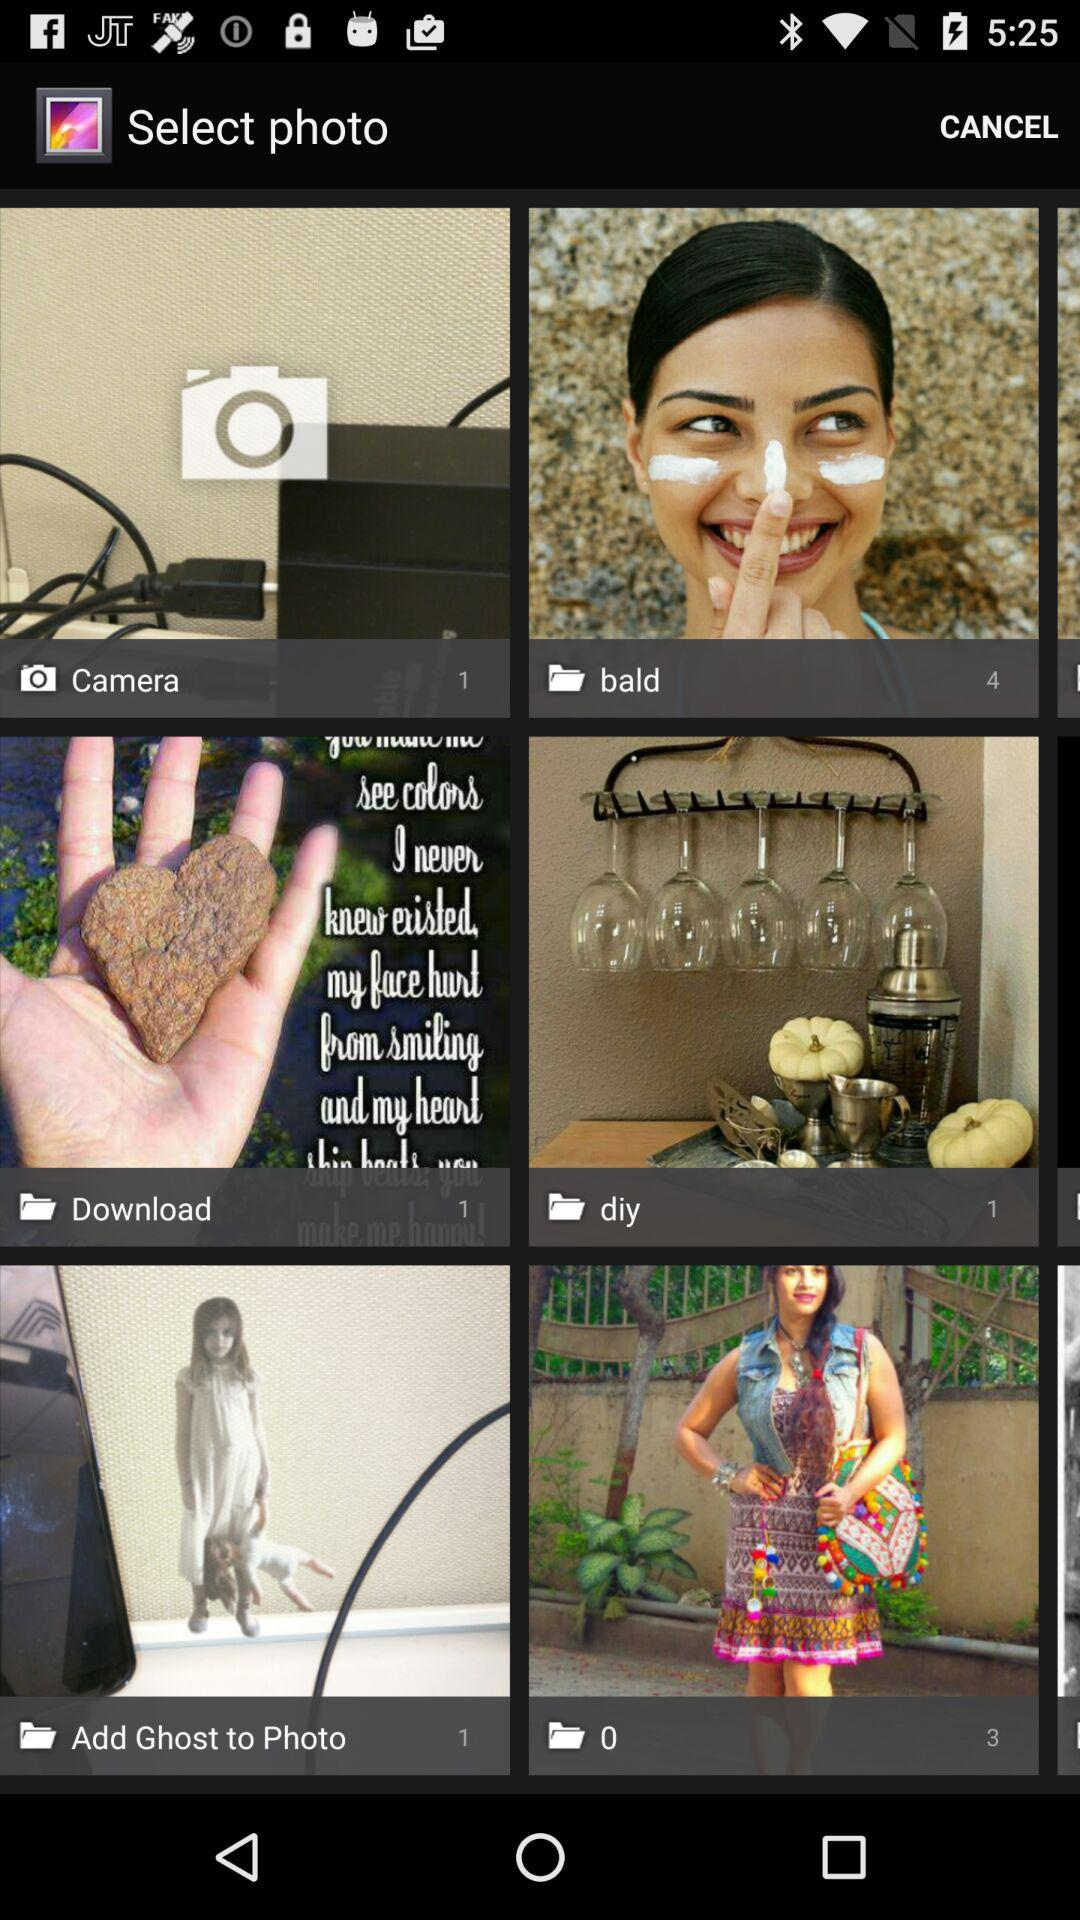How many photos are in the "bald" folder? There are 4 photos in the "bald" folder. 